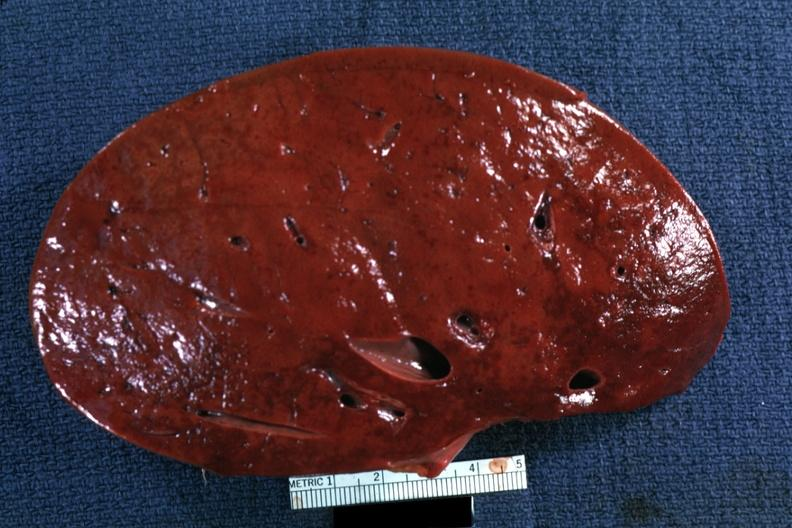s hodgkins disease present?
Answer the question using a single word or phrase. Yes 